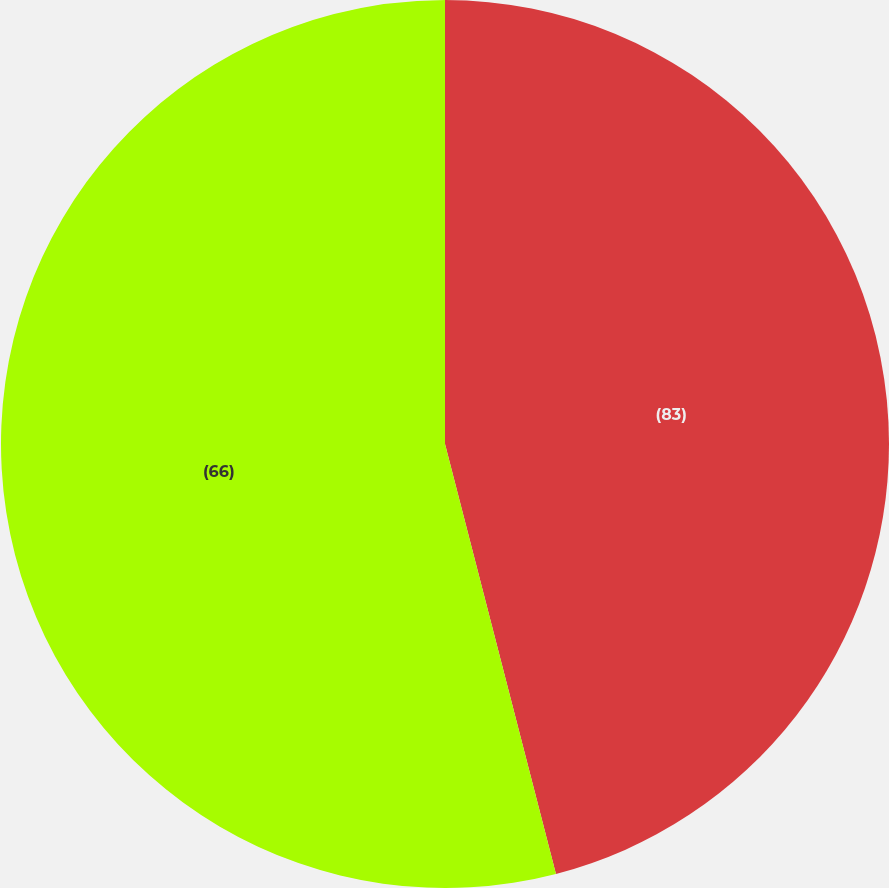Convert chart to OTSL. <chart><loc_0><loc_0><loc_500><loc_500><pie_chart><fcel>(83)<fcel>(66)<nl><fcel>45.98%<fcel>54.02%<nl></chart> 